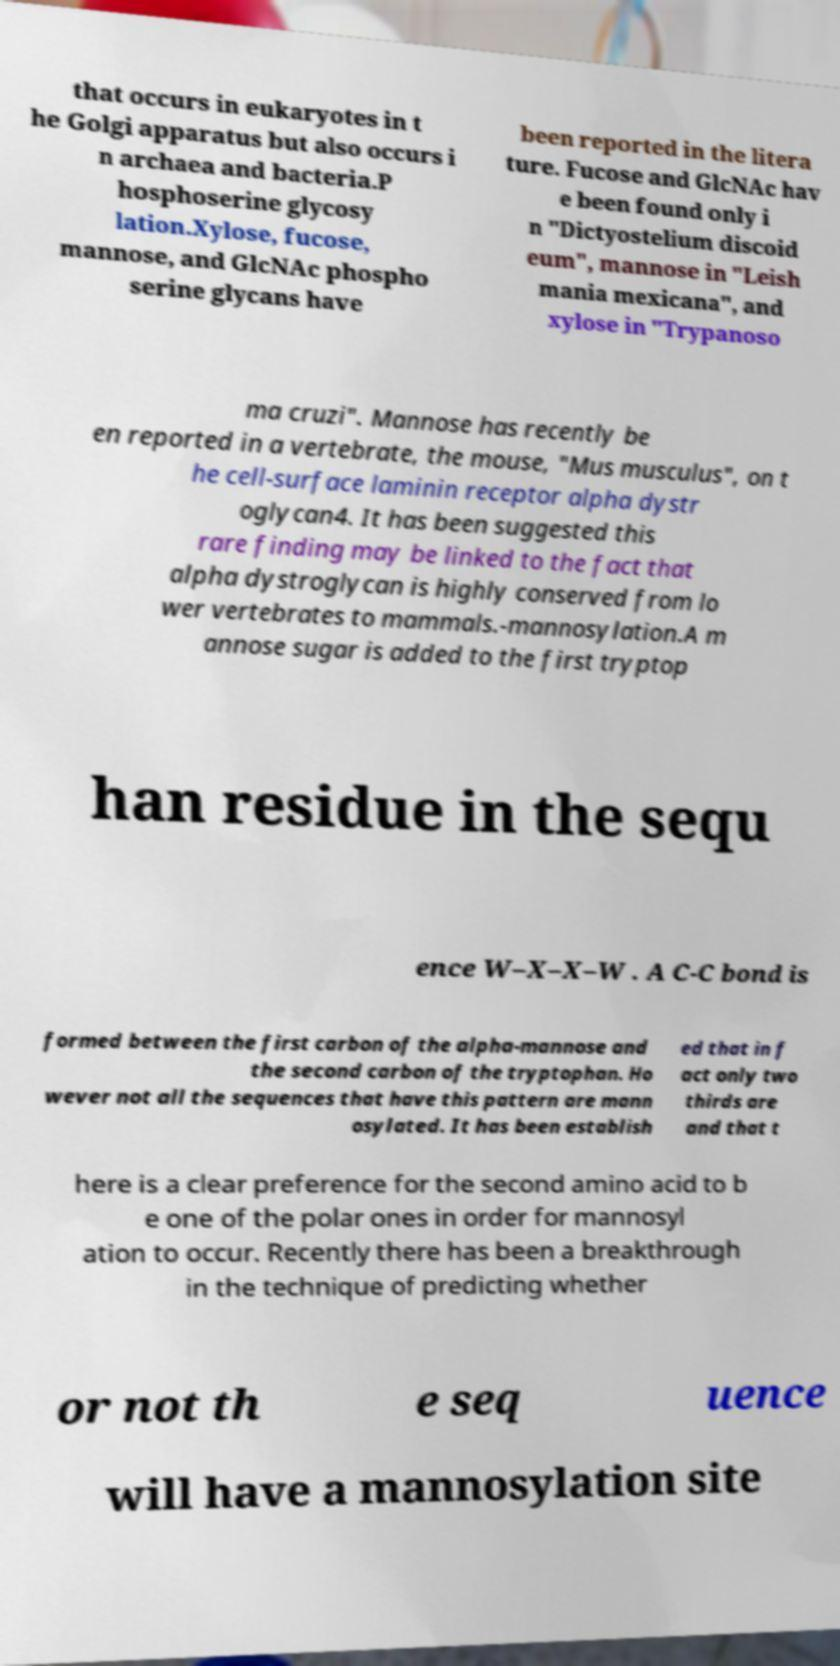I need the written content from this picture converted into text. Can you do that? that occurs in eukaryotes in t he Golgi apparatus but also occurs i n archaea and bacteria.P hosphoserine glycosy lation.Xylose, fucose, mannose, and GlcNAc phospho serine glycans have been reported in the litera ture. Fucose and GlcNAc hav e been found only i n "Dictyostelium discoid eum", mannose in "Leish mania mexicana", and xylose in "Trypanoso ma cruzi". Mannose has recently be en reported in a vertebrate, the mouse, "Mus musculus", on t he cell-surface laminin receptor alpha dystr oglycan4. It has been suggested this rare finding may be linked to the fact that alpha dystroglycan is highly conserved from lo wer vertebrates to mammals.-mannosylation.A m annose sugar is added to the first tryptop han residue in the sequ ence W–X–X–W . A C-C bond is formed between the first carbon of the alpha-mannose and the second carbon of the tryptophan. Ho wever not all the sequences that have this pattern are mann osylated. It has been establish ed that in f act only two thirds are and that t here is a clear preference for the second amino acid to b e one of the polar ones in order for mannosyl ation to occur. Recently there has been a breakthrough in the technique of predicting whether or not th e seq uence will have a mannosylation site 